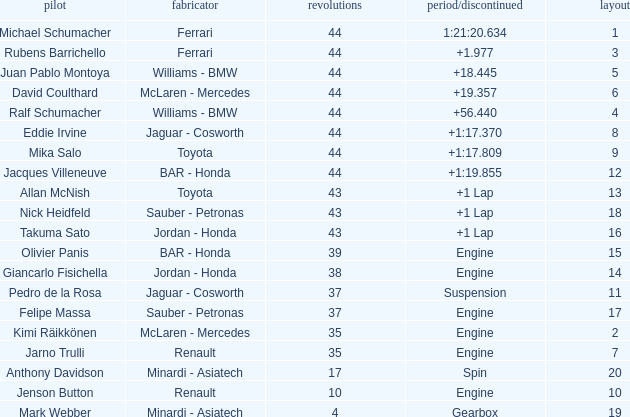I'm looking to parse the entire table for insights. Could you assist me with that? {'header': ['pilot', 'fabricator', 'revolutions', 'period/discontinued', 'layout'], 'rows': [['Michael Schumacher', 'Ferrari', '44', '1:21:20.634', '1'], ['Rubens Barrichello', 'Ferrari', '44', '+1.977', '3'], ['Juan Pablo Montoya', 'Williams - BMW', '44', '+18.445', '5'], ['David Coulthard', 'McLaren - Mercedes', '44', '+19.357', '6'], ['Ralf Schumacher', 'Williams - BMW', '44', '+56.440', '4'], ['Eddie Irvine', 'Jaguar - Cosworth', '44', '+1:17.370', '8'], ['Mika Salo', 'Toyota', '44', '+1:17.809', '9'], ['Jacques Villeneuve', 'BAR - Honda', '44', '+1:19.855', '12'], ['Allan McNish', 'Toyota', '43', '+1 Lap', '13'], ['Nick Heidfeld', 'Sauber - Petronas', '43', '+1 Lap', '18'], ['Takuma Sato', 'Jordan - Honda', '43', '+1 Lap', '16'], ['Olivier Panis', 'BAR - Honda', '39', 'Engine', '15'], ['Giancarlo Fisichella', 'Jordan - Honda', '38', 'Engine', '14'], ['Pedro de la Rosa', 'Jaguar - Cosworth', '37', 'Suspension', '11'], ['Felipe Massa', 'Sauber - Petronas', '37', 'Engine', '17'], ['Kimi Räikkönen', 'McLaren - Mercedes', '35', 'Engine', '2'], ['Jarno Trulli', 'Renault', '35', 'Engine', '7'], ['Anthony Davidson', 'Minardi - Asiatech', '17', 'Spin', '20'], ['Jenson Button', 'Renault', '10', 'Engine', '10'], ['Mark Webber', 'Minardi - Asiatech', '4', 'Gearbox', '19']]} What was the fewest laps for somone who finished +18.445? 44.0. 